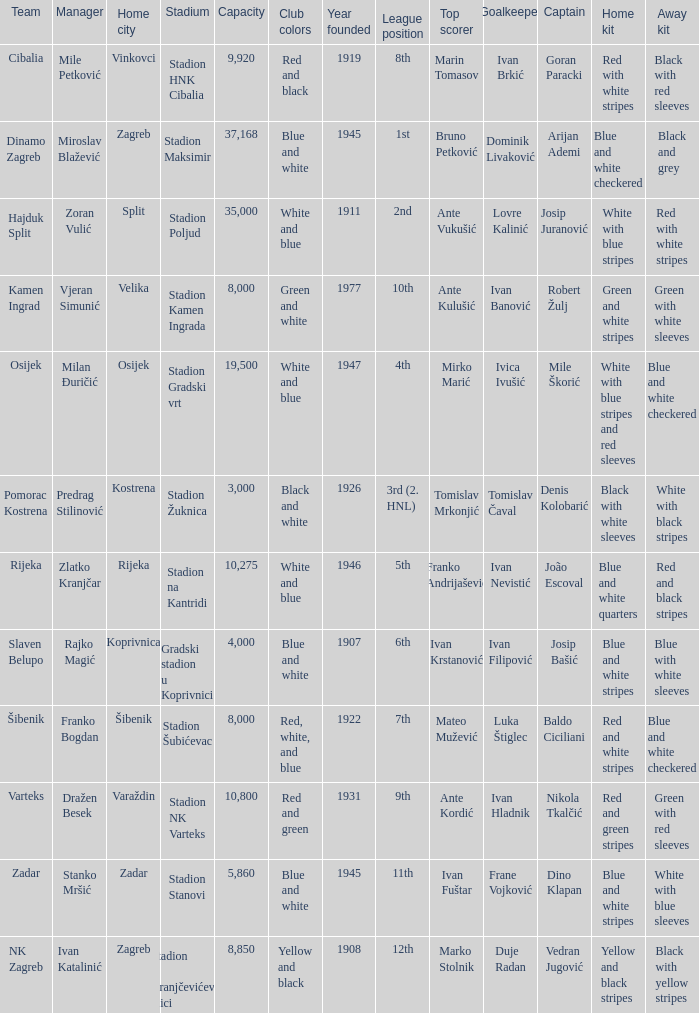What team has a home city of Velika? Kamen Ingrad. 